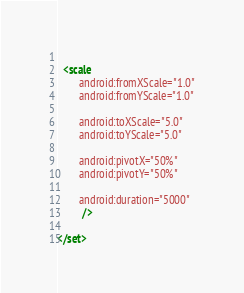<code> <loc_0><loc_0><loc_500><loc_500><_XML_>  
  <scale
        android:fromXScale="1.0"
        android:fromYScale="1.0"
         
        android:toXScale="5.0"
        android:toYScale="5.0"
        
        android:pivotX="50%"
        android:pivotY="50%"
        
        android:duration="5000"
         />
         
</set></code> 